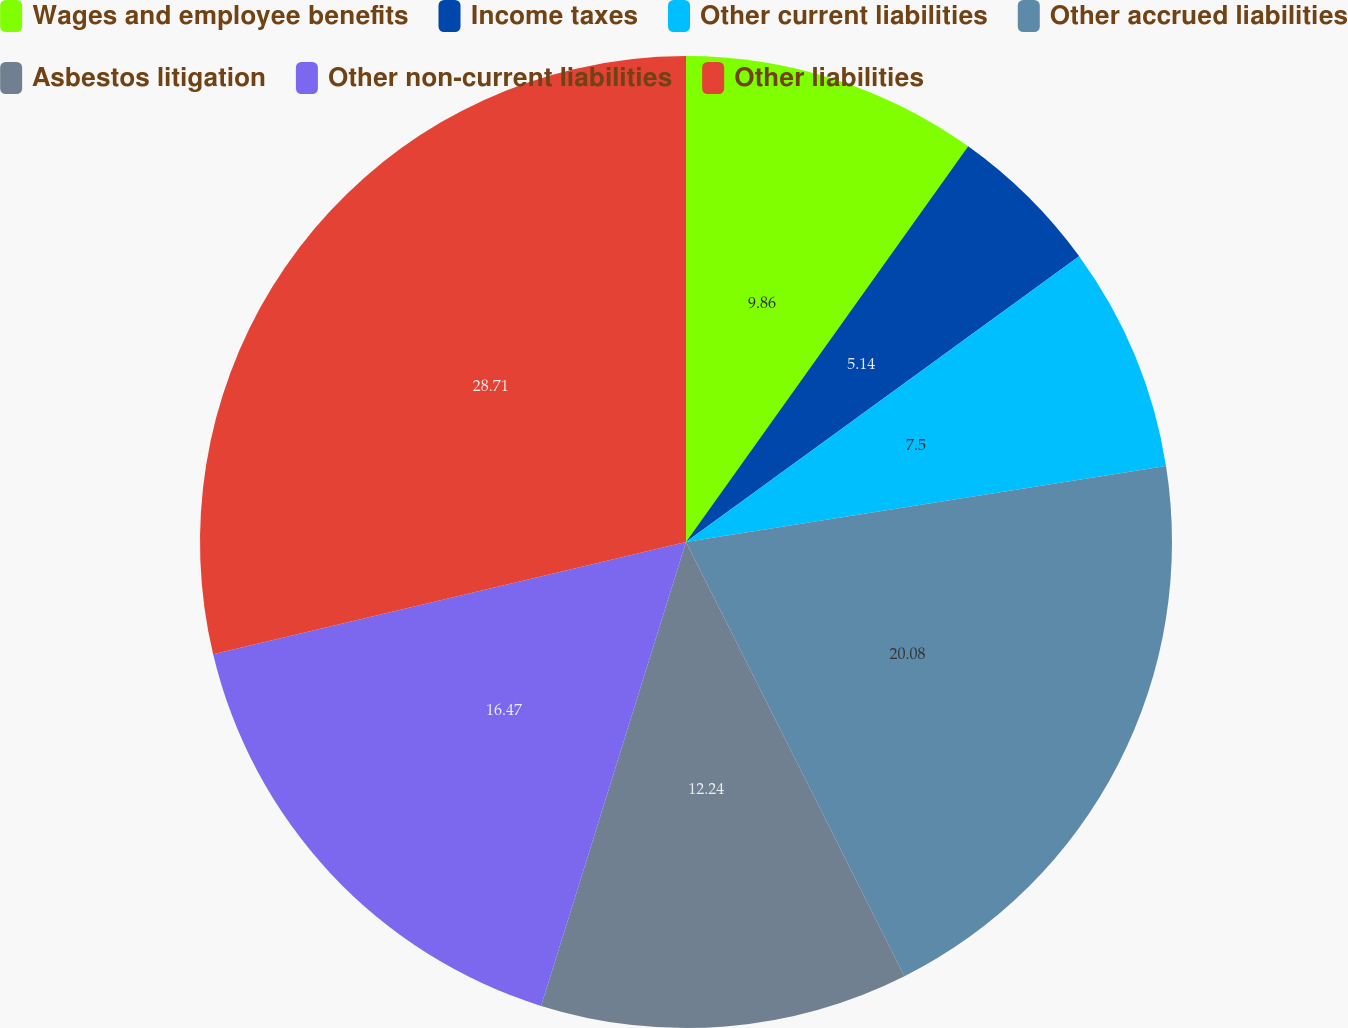Convert chart. <chart><loc_0><loc_0><loc_500><loc_500><pie_chart><fcel>Wages and employee benefits<fcel>Income taxes<fcel>Other current liabilities<fcel>Other accrued liabilities<fcel>Asbestos litigation<fcel>Other non-current liabilities<fcel>Other liabilities<nl><fcel>9.86%<fcel>5.14%<fcel>7.5%<fcel>20.08%<fcel>12.24%<fcel>16.47%<fcel>28.71%<nl></chart> 